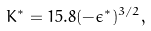<formula> <loc_0><loc_0><loc_500><loc_500>K ^ { * } = 1 5 . 8 ( - \epsilon ^ { * } ) ^ { 3 / 2 } ,</formula> 